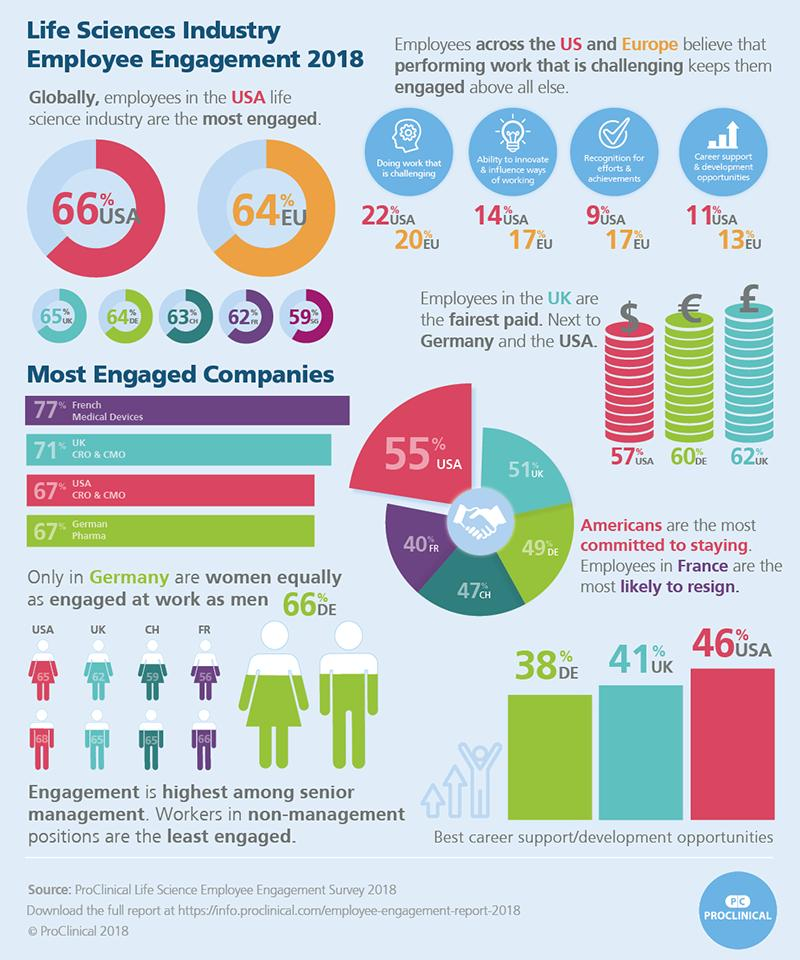Highlight a few significant elements in this photo. In 2018, it was reported that 62% of women in the UK were engaged at work. In 2018, it was reported that approximately 66% of men in France were engaged in their work. In 2018, approximately 20% of employees across Europe reported that their work was challenging. According to a survey conducted in 2018, 38% of the best career support and development opportunities were found in Germany. According to data from 2018, 41% of the best career support and development opportunities were found in the United Kingdom. 